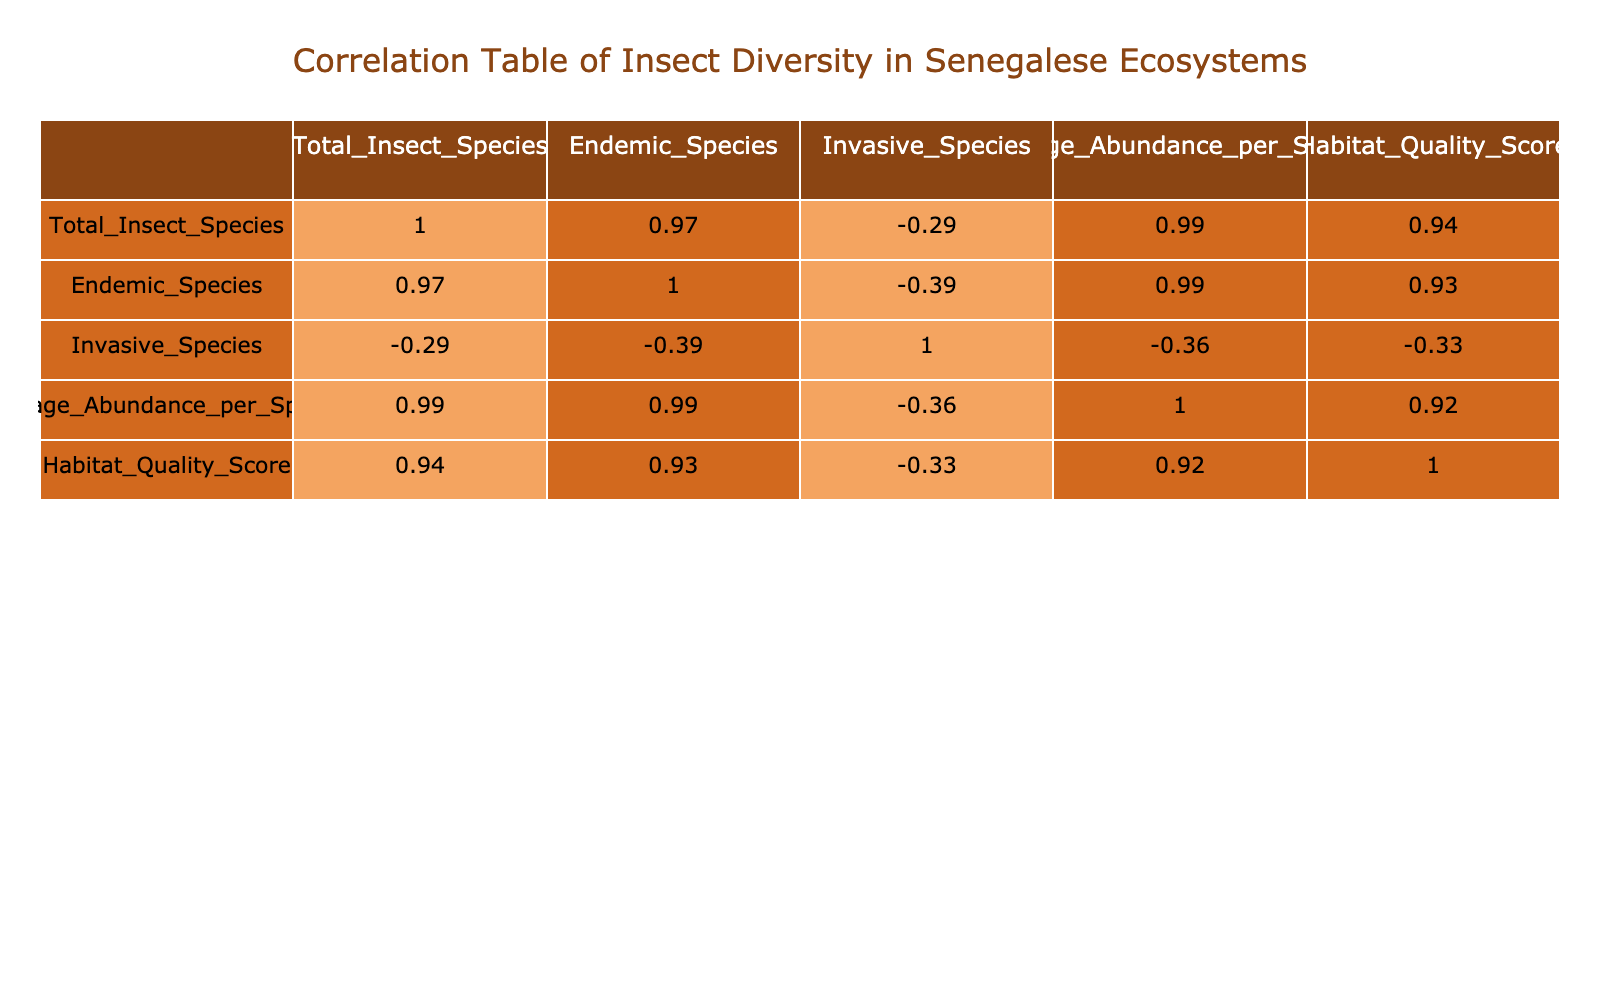What is the total number of insect species in the Forest ecosystem? The total number of insect species in the Forest ecosystem is directly listed under the Total_Insect_Species column in the table. In this case, it shows 180 species.
Answer: 180 Which ecosystem has the highest Habitat Quality Score? By reviewing the Habitat_Quality_Score column, we identify the highest value present in the table. The Forest ecosystem has a score of 8.0, which is the highest among all ecosystems listed.
Answer: 8.0 Is it true that Urban Areas have more invasive species than the Savanna ecosystem? Looking at the Invasive_Species column, Urban Areas have 20 invasive species, while the Savanna ecosystem has 10. Therefore, the statement is true.
Answer: True What is the average number of Endemic Species across all ecosystems? To calculate the average number of Endemic Species, we sum the values in the Endemic_Species column (25 + 15 + 20 + 30 + 10 + 12 + 5 = 117) and divide by the number of ecosystems (7). Thus, the average is 117/7 = approximately 16.71.
Answer: 16.71 Which ecosystem has the lowest Average Abundance per Species? We can identify this by checking the Average_Abundance_per_Species column. The Desert ecosystem has the lowest value of 150 among all the ecosystems listed in the table.
Answer: 150 What is the difference in Total Insect Species between the Wetland and the Agricultural Land ecosystems? To find this difference, we subtract the Total Insect Species number in Agricultural Land (110) from that in Wetland (120), which gives us 120 - 110 = 10.
Answer: 10 What is the correlation between Average Abundance per Species and Habitat Quality Score? By examining the correlation table, we see how these two attributes relate to each other. A correlation value of 0.90 indicates a strong positive correlation between Average Abundance per Species and Habitat Quality Score.
Answer: 0.90 How many ecosystems have more than 100 Total Insect Species? We count the ecosystems with Total Insect Species greater than 100 by checking each value in that column. The ecosystems are Savanna (150), Wetland (120), and Forest (180), totaling three ecosystems.
Answer: 3 